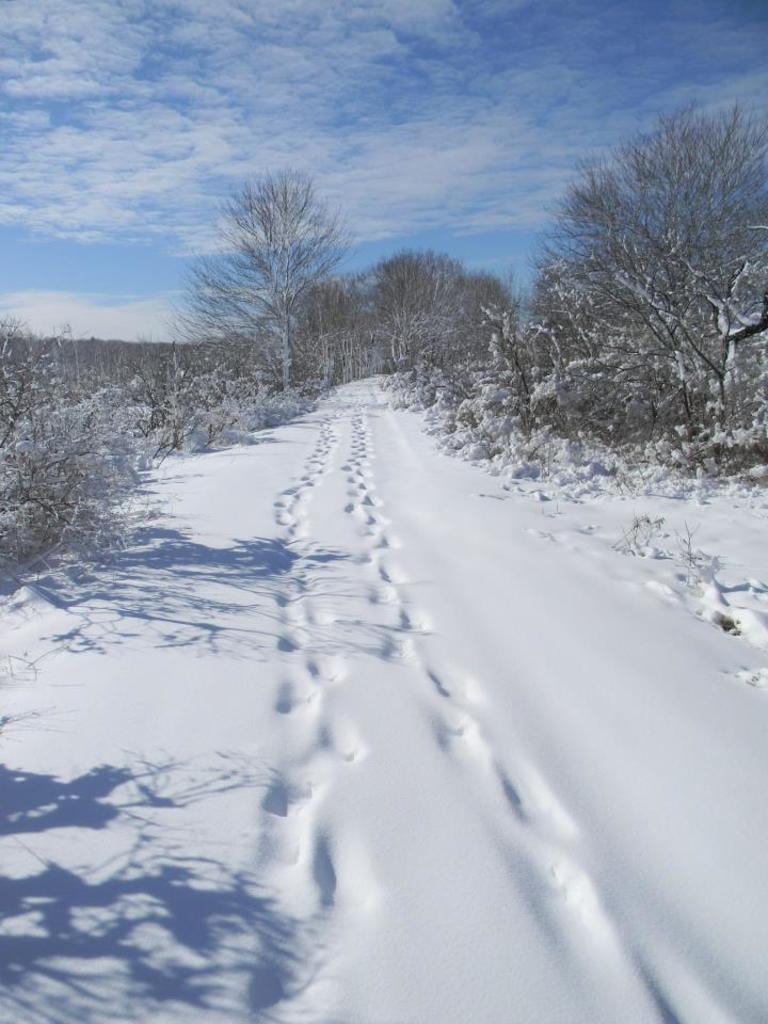Describe this image in one or two sentences. Here we can see snow on the ground. In the background there are bare trees and clouds in the sky. 